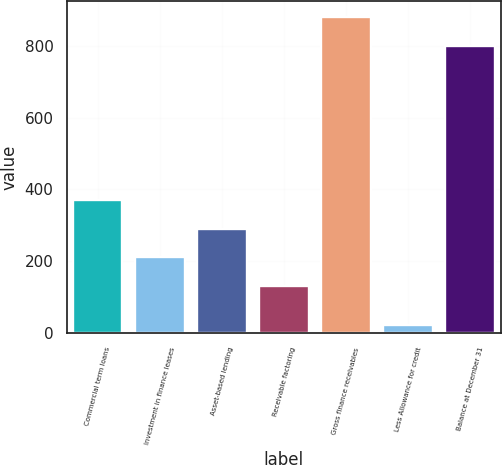<chart> <loc_0><loc_0><loc_500><loc_500><bar_chart><fcel>Commercial term loans<fcel>Investment in finance leases<fcel>Asset-based lending<fcel>Receivable factoring<fcel>Gross finance receivables<fcel>Less Allowance for credit<fcel>Balance at December 31<nl><fcel>371<fcel>211<fcel>291<fcel>131<fcel>880<fcel>22<fcel>800<nl></chart> 